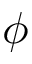Convert formula to latex. <formula><loc_0><loc_0><loc_500><loc_500>\phi</formula> 